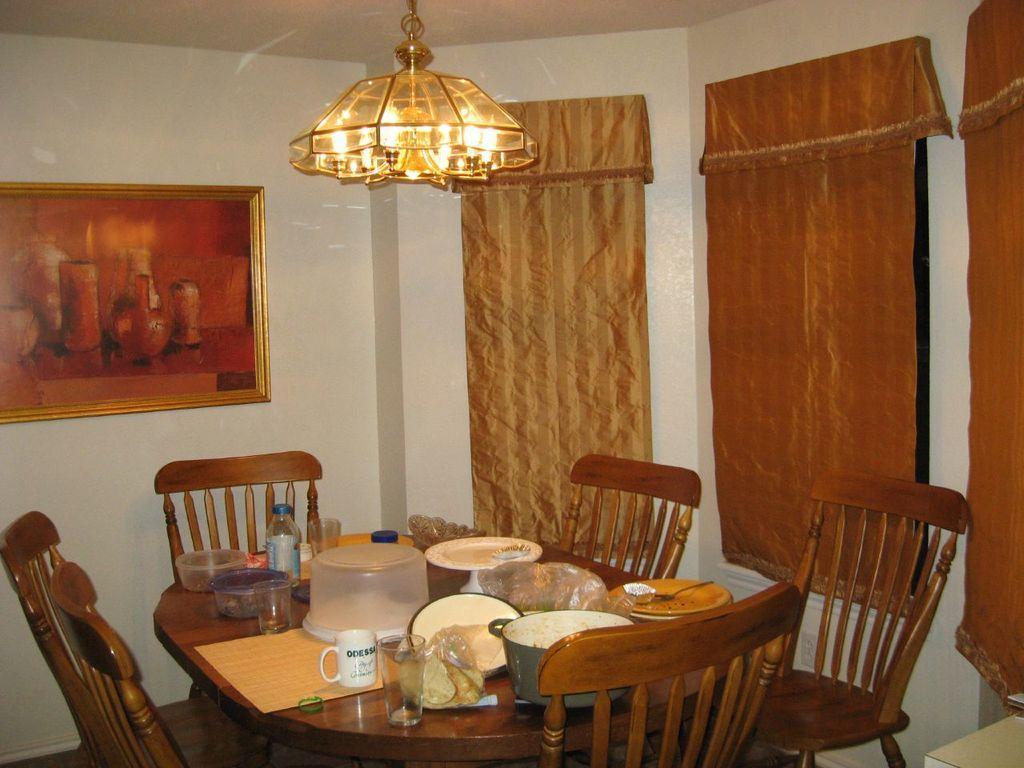Please provide a concise description of this image. In this image, we can see a bottle, glasses, jars, vessels and some food items and some other objects on the table and in the background, there are chairs and we can see curtains and there is a frame on the wall. At the top, there are lights. 